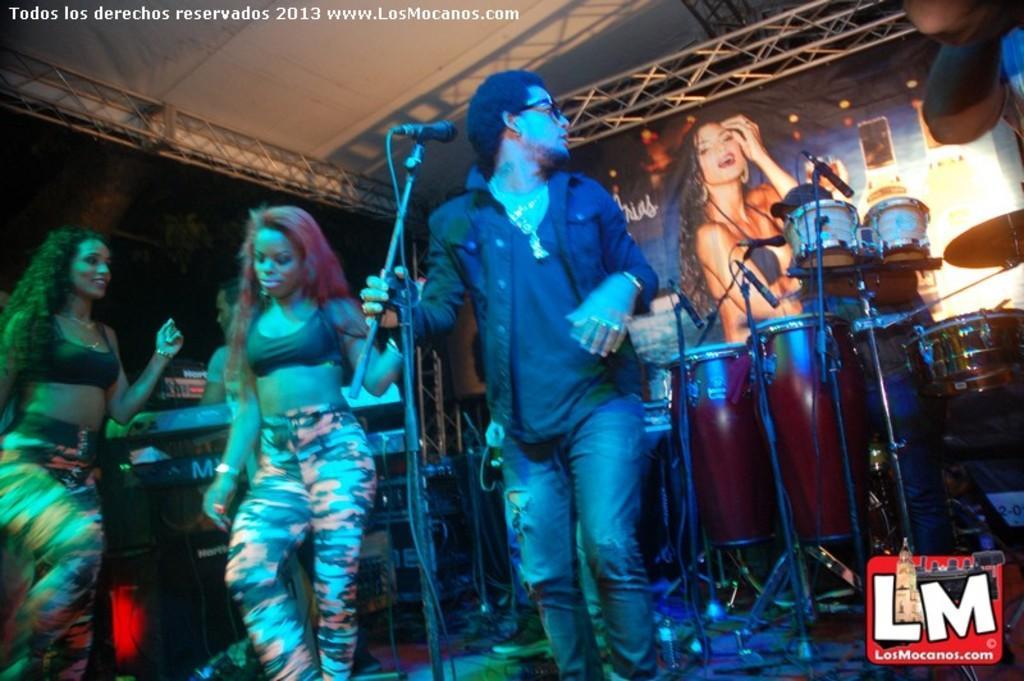Please provide a concise description of this image. In this image I can see group of people standing and I can also see the person standing in front of the microphone. In the background I can see few musical instruments and few lights. 